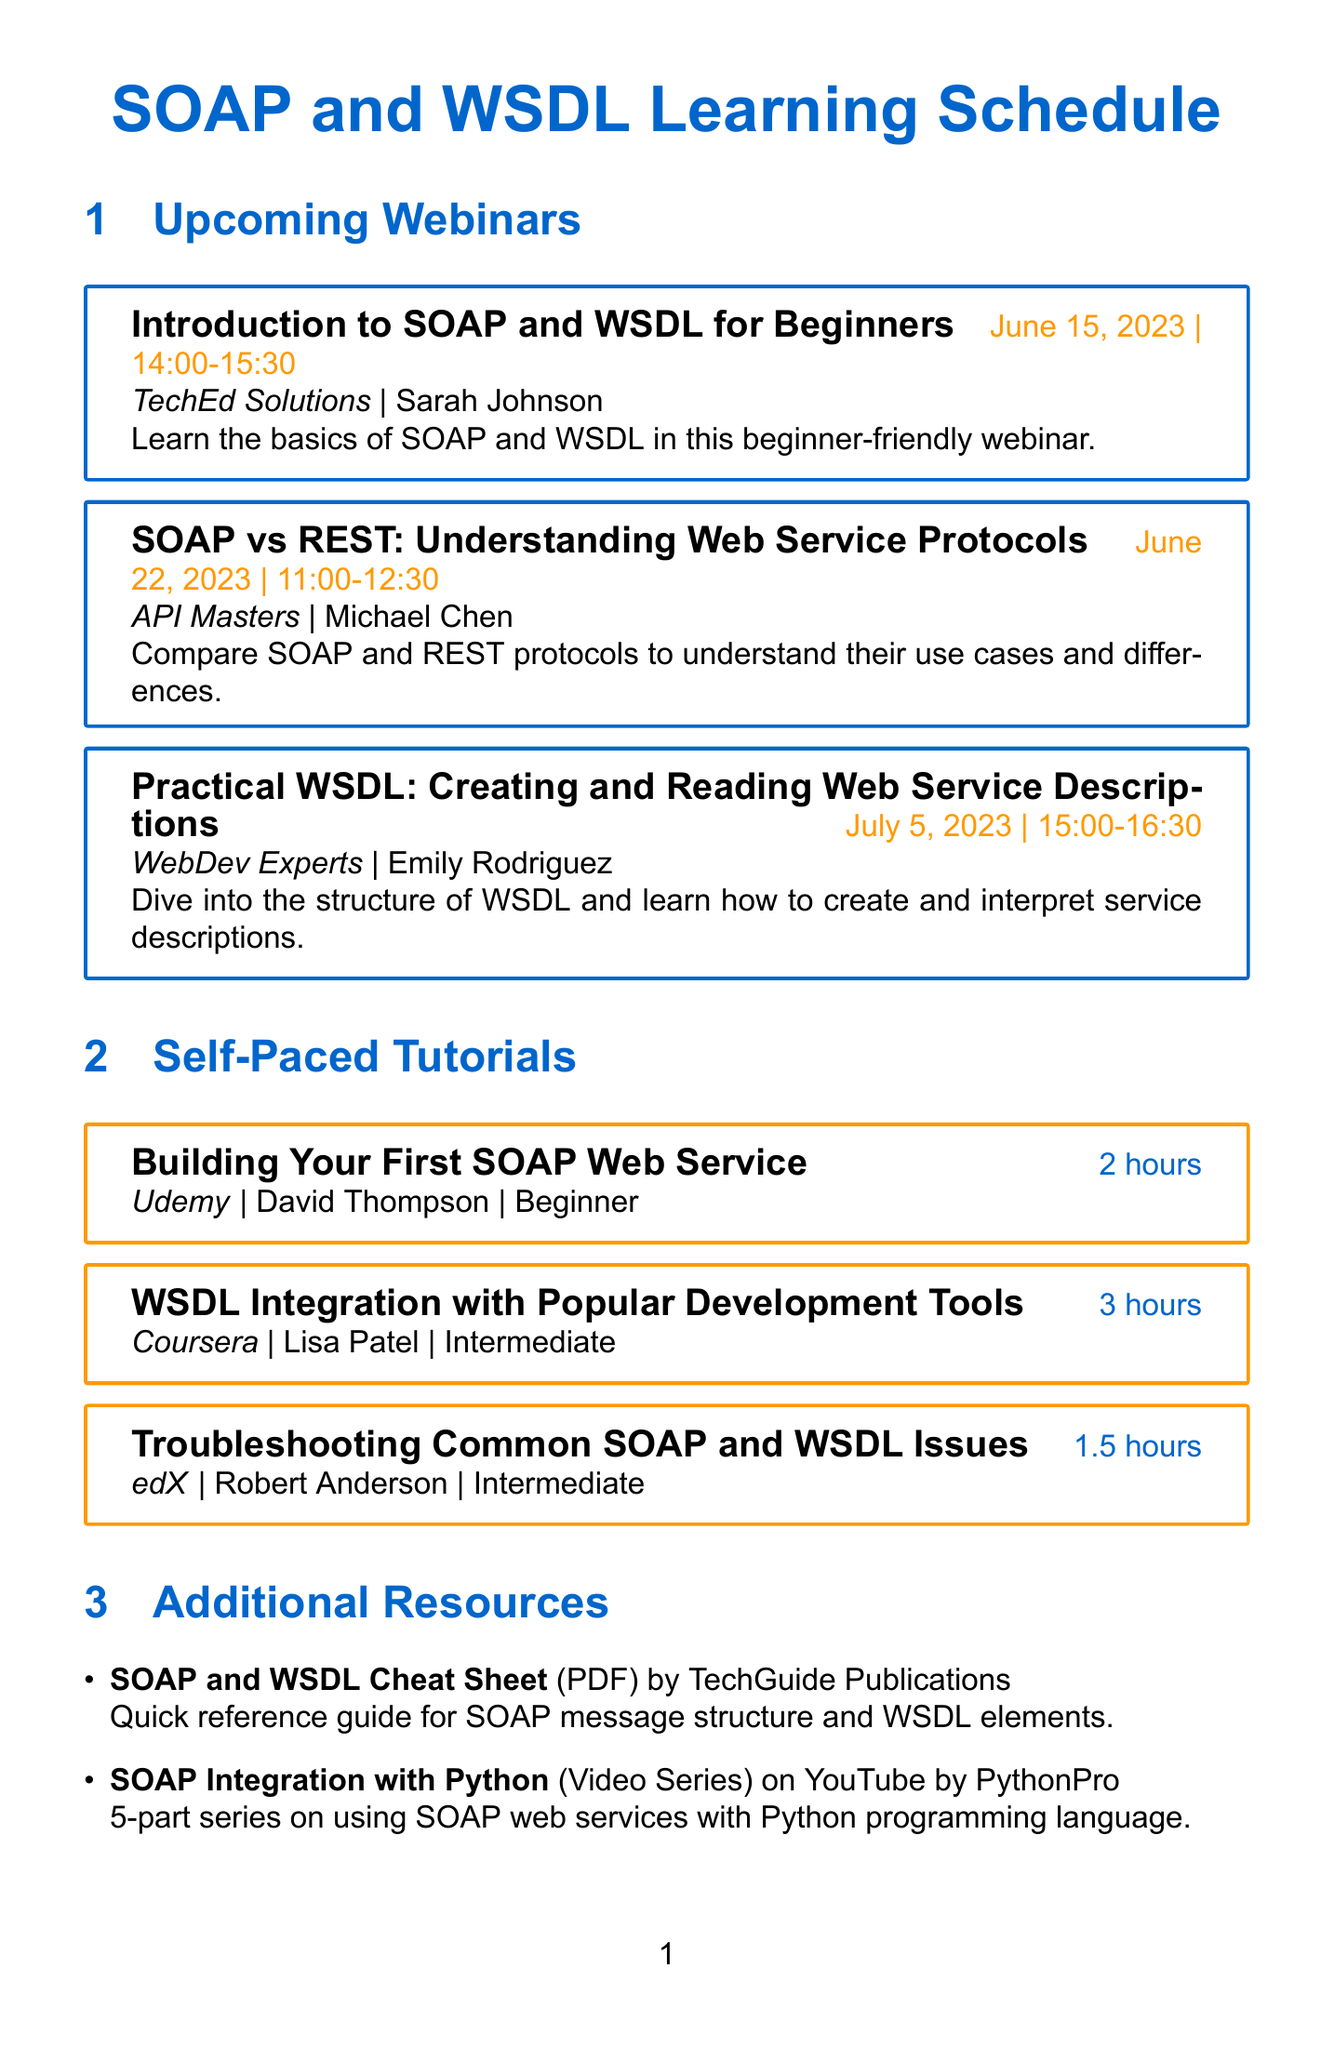What is the title of the first webinar? The first webinar is titled "Introduction to SOAP and WSDL for Beginners."
Answer: Introduction to SOAP and WSDL for Beginners Who is the presenter for the webinar on SOAP vs REST? The webinar compares SOAP and REST, presented by Michael Chen.
Answer: Michael Chen What date is the Practical WSDL webinar scheduled for? The Practical WSDL webinar is set for July 5, 2023.
Answer: July 5, 2023 How long is the tutorial on Building Your First SOAP Web Service? The duration of the tutorial is 2 hours.
Answer: 2 hours Which platform offers the WSDL Integration tutorial? The tutorial on WSDL Integration is available on Coursera.
Answer: Coursera What type of resource is the SOAP and WSDL Cheat Sheet? The Cheat Sheet is categorized as a PDF.
Answer: PDF Name the instructor of the tutorial on Troubleshooting Common SOAP and WSDL Issues. The instructor for the troubleshooting tutorial is Robert Anderson.
Answer: Robert Anderson How many hours is the tutorial on WSDL Integration with Popular Development Tools? The tutorial lasts for 3 hours.
Answer: 3 hours What is the primary focus of the blog post by Alex Wong? The focus of the blog post is on XML Schema and its role in WSDL documents.
Answer: XML Schema and its role in WSDL documents 